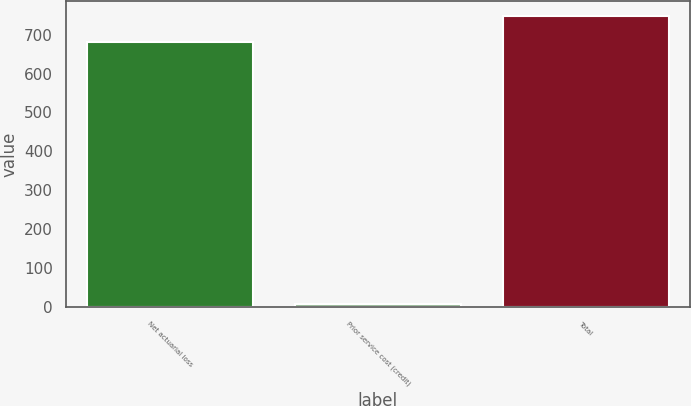Convert chart to OTSL. <chart><loc_0><loc_0><loc_500><loc_500><bar_chart><fcel>Net actuarial loss<fcel>Prior service cost (credit)<fcel>Total<nl><fcel>680.4<fcel>6.6<fcel>748.44<nl></chart> 